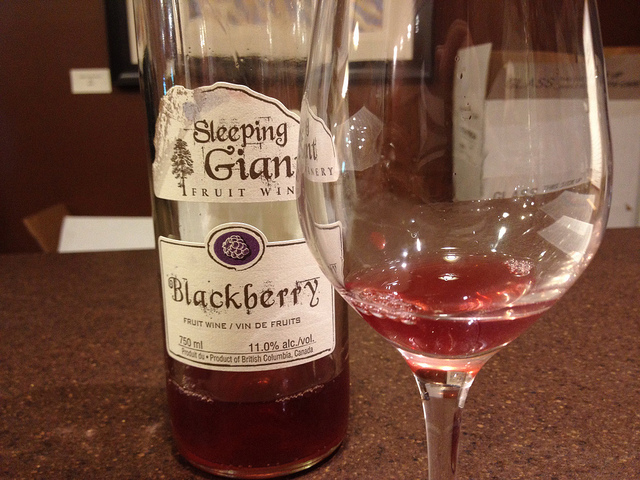Read all the text in this image. FRUIT WIN Gian FRUIT WINE ss Canada Columbia Product 750 alc 0 11 FRUITS DE VIN Blackberry Sleeping 